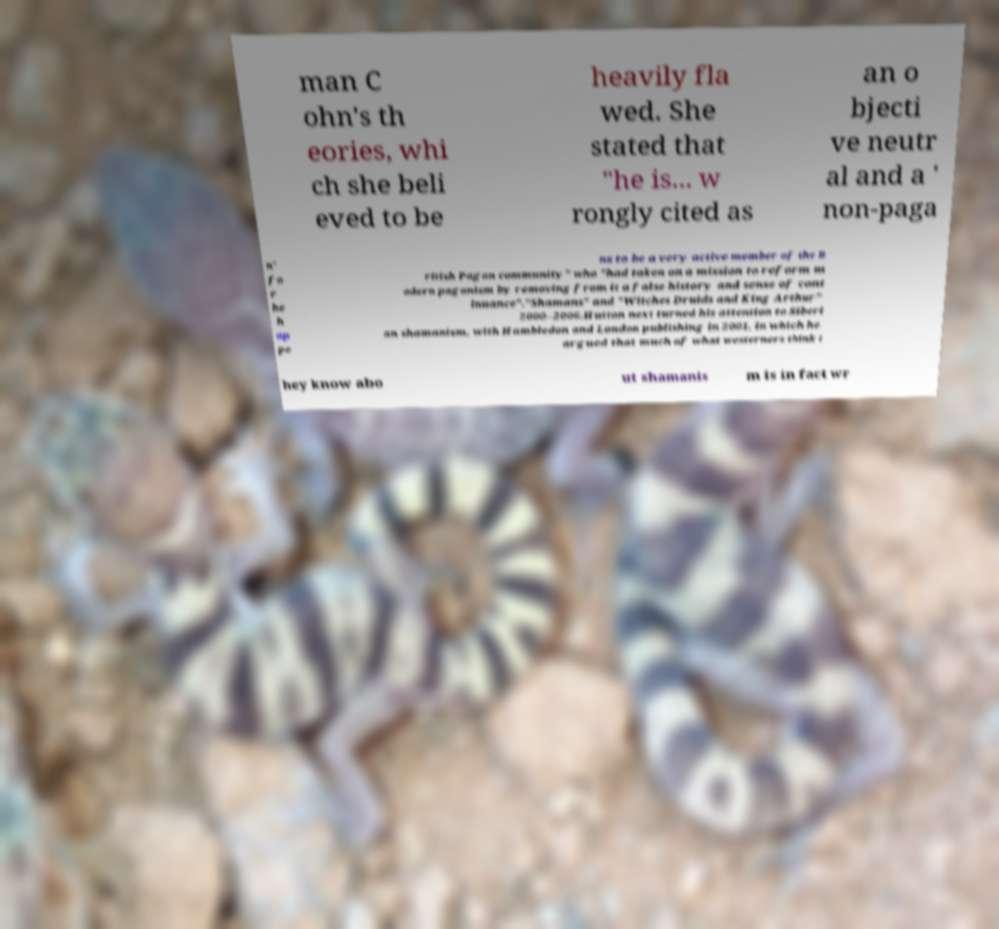Could you assist in decoding the text presented in this image and type it out clearly? man C ohn's th eories, whi ch she beli eved to be heavily fla wed. She stated that "he is... w rongly cited as an o bjecti ve neutr al and a ' non-paga n' fo r he h ap pe ns to be a very active member of the B ritish Pagan community" who "had taken on a mission to reform m odern paganism by removing from it a false history and sense of cont inuance"."Shamans" and "Witches Druids and King Arthur" 2000–2006.Hutton next turned his attention to Siberi an shamanism, with Hambledon and London publishing in 2001, in which he argued that much of what westerners think t hey know abo ut shamanis m is in fact wr 